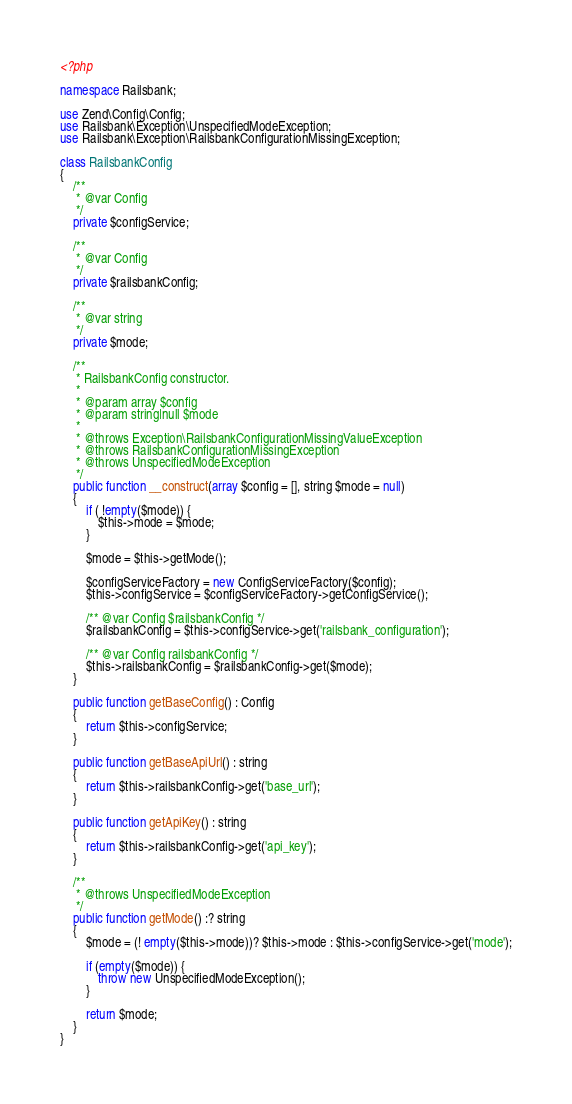Convert code to text. <code><loc_0><loc_0><loc_500><loc_500><_PHP_><?php

namespace Railsbank;

use Zend\Config\Config;
use Railsbank\Exception\UnspecifiedModeException;
use Railsbank\Exception\RailsbankConfigurationMissingException;

class RailsbankConfig
{
    /**
     * @var Config
     */
    private $configService;

    /**
     * @var Config
     */
    private $railsbankConfig;

    /**
     * @var string
     */
    private $mode;

    /**
     * RailsbankConfig constructor.
     *
     * @param array $config
     * @param string|null $mode
     *
     * @throws Exception\RailsbankConfigurationMissingValueException
     * @throws RailsbankConfigurationMissingException
     * @throws UnspecifiedModeException
     */
    public function __construct(array $config = [], string $mode = null)
    {
        if ( !empty($mode)) {
            $this->mode = $mode;
        }

        $mode = $this->getMode();

        $configServiceFactory = new ConfigServiceFactory($config);
        $this->configService = $configServiceFactory->getConfigService();

        /** @var Config $railsbankConfig */
        $railsbankConfig = $this->configService->get('railsbank_configuration');

        /** @var Config railsbankConfig */
        $this->railsbankConfig = $railsbankConfig->get($mode);
    }

    public function getBaseConfig() : Config
    {
        return $this->configService;
    }

    public function getBaseApiUrl() : string
    {
        return $this->railsbankConfig->get('base_url');
    }

    public function getApiKey() : string
    {
        return $this->railsbankConfig->get('api_key');
    }

    /**
     * @throws UnspecifiedModeException
     */
    public function getMode() :? string
    {
        $mode = (! empty($this->mode))? $this->mode : $this->configService->get('mode');

        if (empty($mode)) {
            throw new UnspecifiedModeException();
        }

        return $mode;
    }
}
</code> 